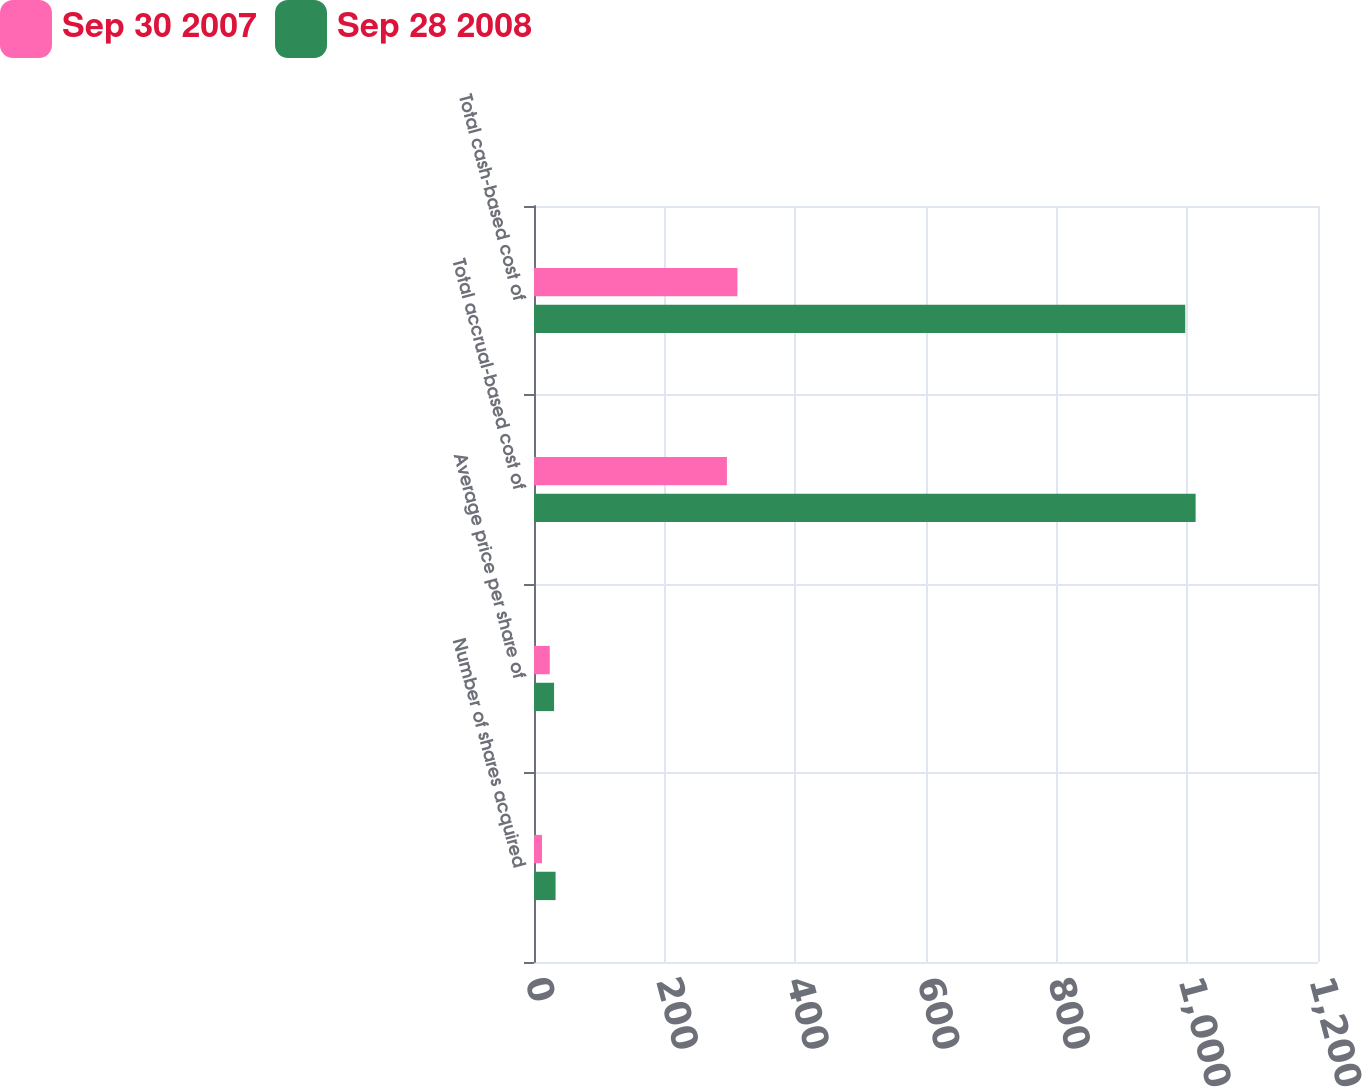<chart> <loc_0><loc_0><loc_500><loc_500><stacked_bar_chart><ecel><fcel>Number of shares acquired<fcel>Average price per share of<fcel>Total accrual-based cost of<fcel>Total cash-based cost of<nl><fcel>Sep 30 2007<fcel>12.2<fcel>24.12<fcel>295.3<fcel>311.4<nl><fcel>Sep 28 2008<fcel>33<fcel>30.72<fcel>1012.7<fcel>996.8<nl></chart> 